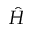Convert formula to latex. <formula><loc_0><loc_0><loc_500><loc_500>\hat { H }</formula> 